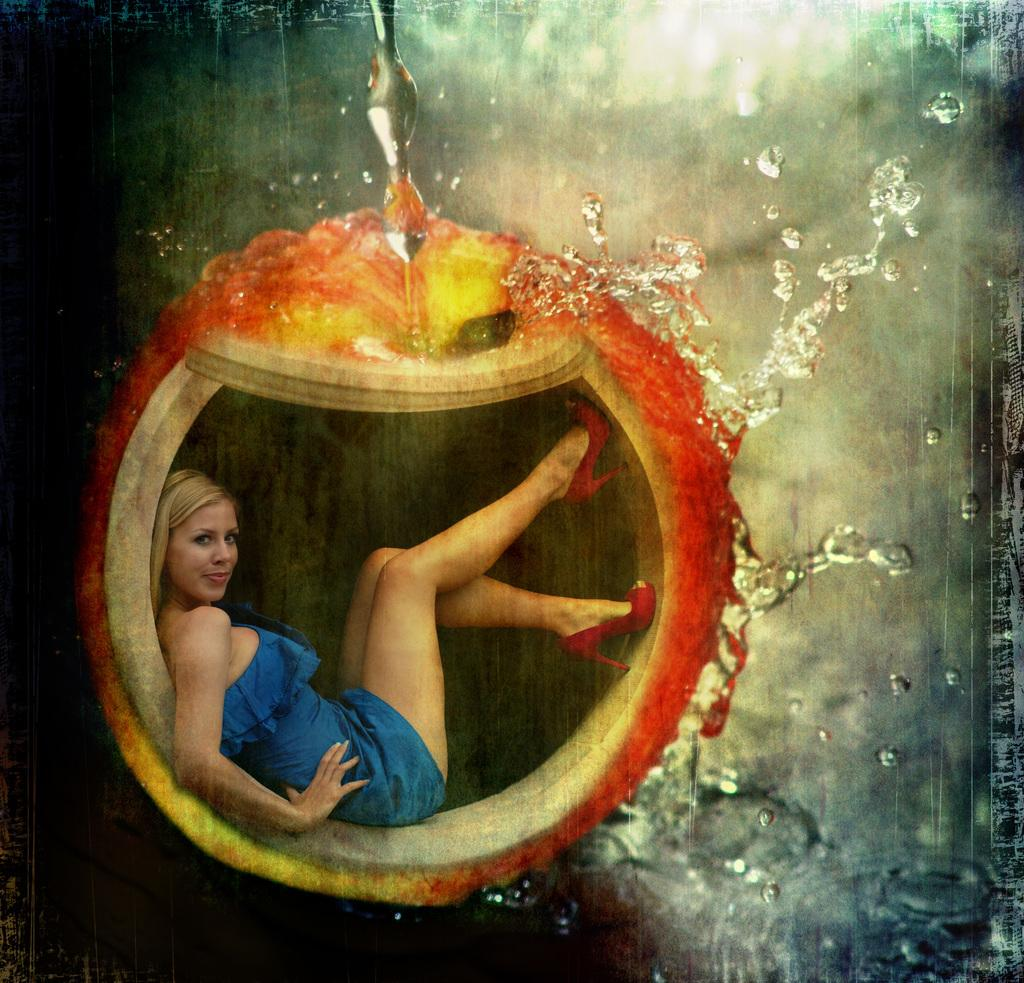What can be observed about the image? The image is edited. Can you describe the subject of the edited image? There is a woman in the edited image. How many cakes are visible on the table in the image? There is no table or cakes present in the image; it only features a woman. Can you describe the family members in the image? There is no family or family members present in the image; it only features a woman. 